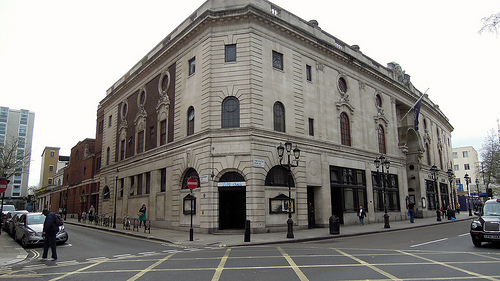<image>
Is there a building in front of the man? No. The building is not in front of the man. The spatial positioning shows a different relationship between these objects. 